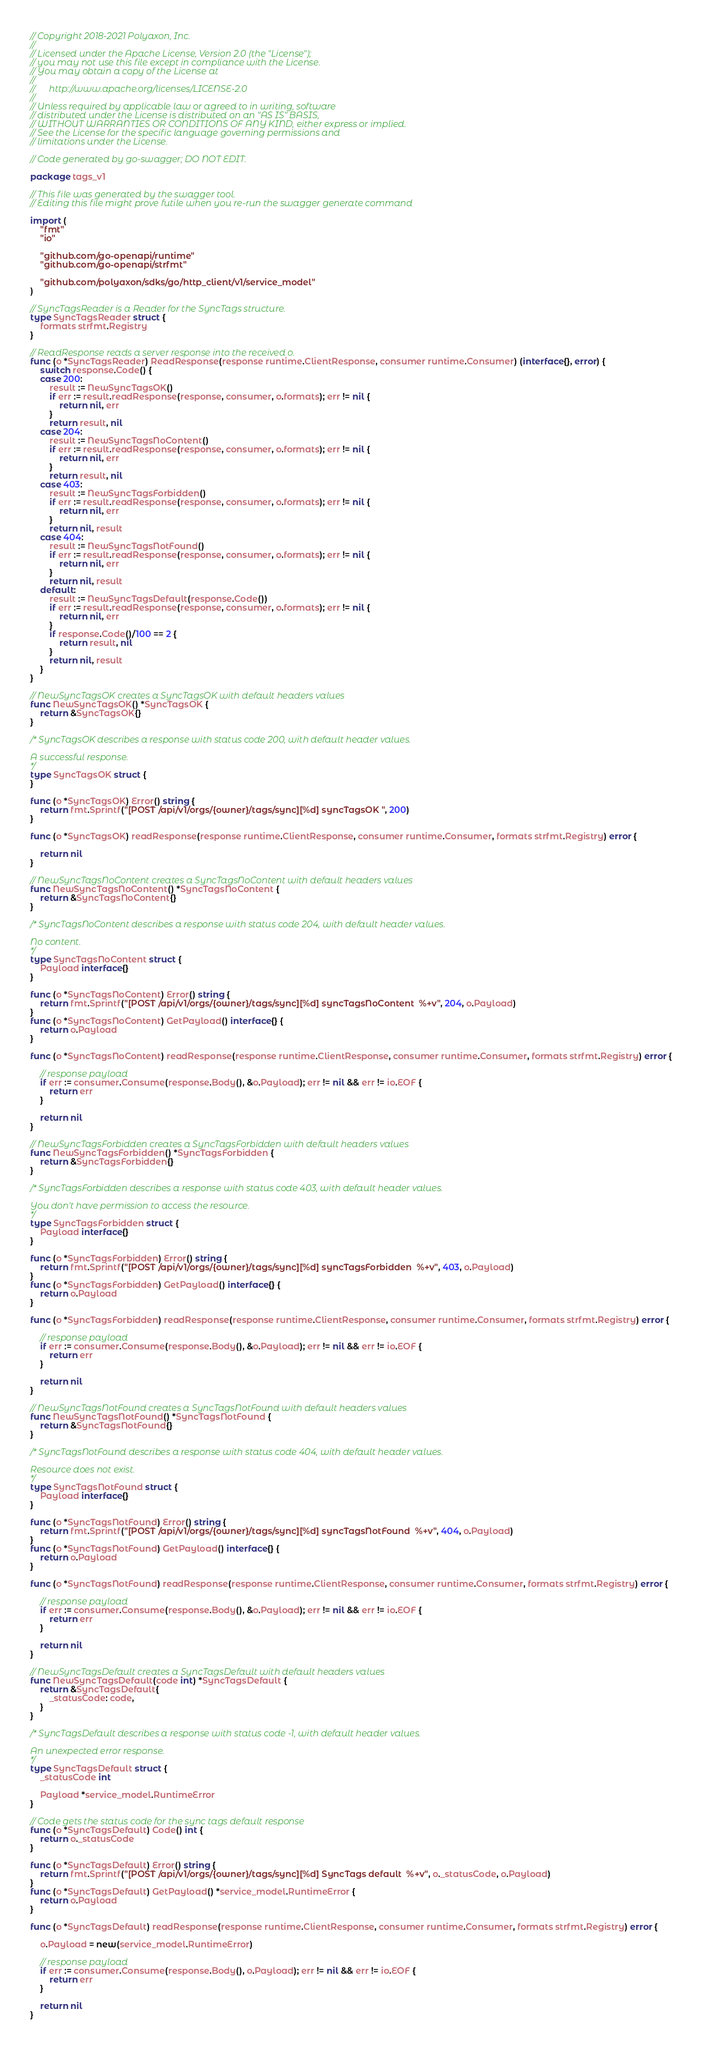<code> <loc_0><loc_0><loc_500><loc_500><_Go_>// Copyright 2018-2021 Polyaxon, Inc.
//
// Licensed under the Apache License, Version 2.0 (the "License");
// you may not use this file except in compliance with the License.
// You may obtain a copy of the License at
//
//      http://www.apache.org/licenses/LICENSE-2.0
//
// Unless required by applicable law or agreed to in writing, software
// distributed under the License is distributed on an "AS IS" BASIS,
// WITHOUT WARRANTIES OR CONDITIONS OF ANY KIND, either express or implied.
// See the License for the specific language governing permissions and
// limitations under the License.

// Code generated by go-swagger; DO NOT EDIT.

package tags_v1

// This file was generated by the swagger tool.
// Editing this file might prove futile when you re-run the swagger generate command

import (
	"fmt"
	"io"

	"github.com/go-openapi/runtime"
	"github.com/go-openapi/strfmt"

	"github.com/polyaxon/sdks/go/http_client/v1/service_model"
)

// SyncTagsReader is a Reader for the SyncTags structure.
type SyncTagsReader struct {
	formats strfmt.Registry
}

// ReadResponse reads a server response into the received o.
func (o *SyncTagsReader) ReadResponse(response runtime.ClientResponse, consumer runtime.Consumer) (interface{}, error) {
	switch response.Code() {
	case 200:
		result := NewSyncTagsOK()
		if err := result.readResponse(response, consumer, o.formats); err != nil {
			return nil, err
		}
		return result, nil
	case 204:
		result := NewSyncTagsNoContent()
		if err := result.readResponse(response, consumer, o.formats); err != nil {
			return nil, err
		}
		return result, nil
	case 403:
		result := NewSyncTagsForbidden()
		if err := result.readResponse(response, consumer, o.formats); err != nil {
			return nil, err
		}
		return nil, result
	case 404:
		result := NewSyncTagsNotFound()
		if err := result.readResponse(response, consumer, o.formats); err != nil {
			return nil, err
		}
		return nil, result
	default:
		result := NewSyncTagsDefault(response.Code())
		if err := result.readResponse(response, consumer, o.formats); err != nil {
			return nil, err
		}
		if response.Code()/100 == 2 {
			return result, nil
		}
		return nil, result
	}
}

// NewSyncTagsOK creates a SyncTagsOK with default headers values
func NewSyncTagsOK() *SyncTagsOK {
	return &SyncTagsOK{}
}

/* SyncTagsOK describes a response with status code 200, with default header values.

A successful response.
*/
type SyncTagsOK struct {
}

func (o *SyncTagsOK) Error() string {
	return fmt.Sprintf("[POST /api/v1/orgs/{owner}/tags/sync][%d] syncTagsOK ", 200)
}

func (o *SyncTagsOK) readResponse(response runtime.ClientResponse, consumer runtime.Consumer, formats strfmt.Registry) error {

	return nil
}

// NewSyncTagsNoContent creates a SyncTagsNoContent with default headers values
func NewSyncTagsNoContent() *SyncTagsNoContent {
	return &SyncTagsNoContent{}
}

/* SyncTagsNoContent describes a response with status code 204, with default header values.

No content.
*/
type SyncTagsNoContent struct {
	Payload interface{}
}

func (o *SyncTagsNoContent) Error() string {
	return fmt.Sprintf("[POST /api/v1/orgs/{owner}/tags/sync][%d] syncTagsNoContent  %+v", 204, o.Payload)
}
func (o *SyncTagsNoContent) GetPayload() interface{} {
	return o.Payload
}

func (o *SyncTagsNoContent) readResponse(response runtime.ClientResponse, consumer runtime.Consumer, formats strfmt.Registry) error {

	// response payload
	if err := consumer.Consume(response.Body(), &o.Payload); err != nil && err != io.EOF {
		return err
	}

	return nil
}

// NewSyncTagsForbidden creates a SyncTagsForbidden with default headers values
func NewSyncTagsForbidden() *SyncTagsForbidden {
	return &SyncTagsForbidden{}
}

/* SyncTagsForbidden describes a response with status code 403, with default header values.

You don't have permission to access the resource.
*/
type SyncTagsForbidden struct {
	Payload interface{}
}

func (o *SyncTagsForbidden) Error() string {
	return fmt.Sprintf("[POST /api/v1/orgs/{owner}/tags/sync][%d] syncTagsForbidden  %+v", 403, o.Payload)
}
func (o *SyncTagsForbidden) GetPayload() interface{} {
	return o.Payload
}

func (o *SyncTagsForbidden) readResponse(response runtime.ClientResponse, consumer runtime.Consumer, formats strfmt.Registry) error {

	// response payload
	if err := consumer.Consume(response.Body(), &o.Payload); err != nil && err != io.EOF {
		return err
	}

	return nil
}

// NewSyncTagsNotFound creates a SyncTagsNotFound with default headers values
func NewSyncTagsNotFound() *SyncTagsNotFound {
	return &SyncTagsNotFound{}
}

/* SyncTagsNotFound describes a response with status code 404, with default header values.

Resource does not exist.
*/
type SyncTagsNotFound struct {
	Payload interface{}
}

func (o *SyncTagsNotFound) Error() string {
	return fmt.Sprintf("[POST /api/v1/orgs/{owner}/tags/sync][%d] syncTagsNotFound  %+v", 404, o.Payload)
}
func (o *SyncTagsNotFound) GetPayload() interface{} {
	return o.Payload
}

func (o *SyncTagsNotFound) readResponse(response runtime.ClientResponse, consumer runtime.Consumer, formats strfmt.Registry) error {

	// response payload
	if err := consumer.Consume(response.Body(), &o.Payload); err != nil && err != io.EOF {
		return err
	}

	return nil
}

// NewSyncTagsDefault creates a SyncTagsDefault with default headers values
func NewSyncTagsDefault(code int) *SyncTagsDefault {
	return &SyncTagsDefault{
		_statusCode: code,
	}
}

/* SyncTagsDefault describes a response with status code -1, with default header values.

An unexpected error response.
*/
type SyncTagsDefault struct {
	_statusCode int

	Payload *service_model.RuntimeError
}

// Code gets the status code for the sync tags default response
func (o *SyncTagsDefault) Code() int {
	return o._statusCode
}

func (o *SyncTagsDefault) Error() string {
	return fmt.Sprintf("[POST /api/v1/orgs/{owner}/tags/sync][%d] SyncTags default  %+v", o._statusCode, o.Payload)
}
func (o *SyncTagsDefault) GetPayload() *service_model.RuntimeError {
	return o.Payload
}

func (o *SyncTagsDefault) readResponse(response runtime.ClientResponse, consumer runtime.Consumer, formats strfmt.Registry) error {

	o.Payload = new(service_model.RuntimeError)

	// response payload
	if err := consumer.Consume(response.Body(), o.Payload); err != nil && err != io.EOF {
		return err
	}

	return nil
}
</code> 